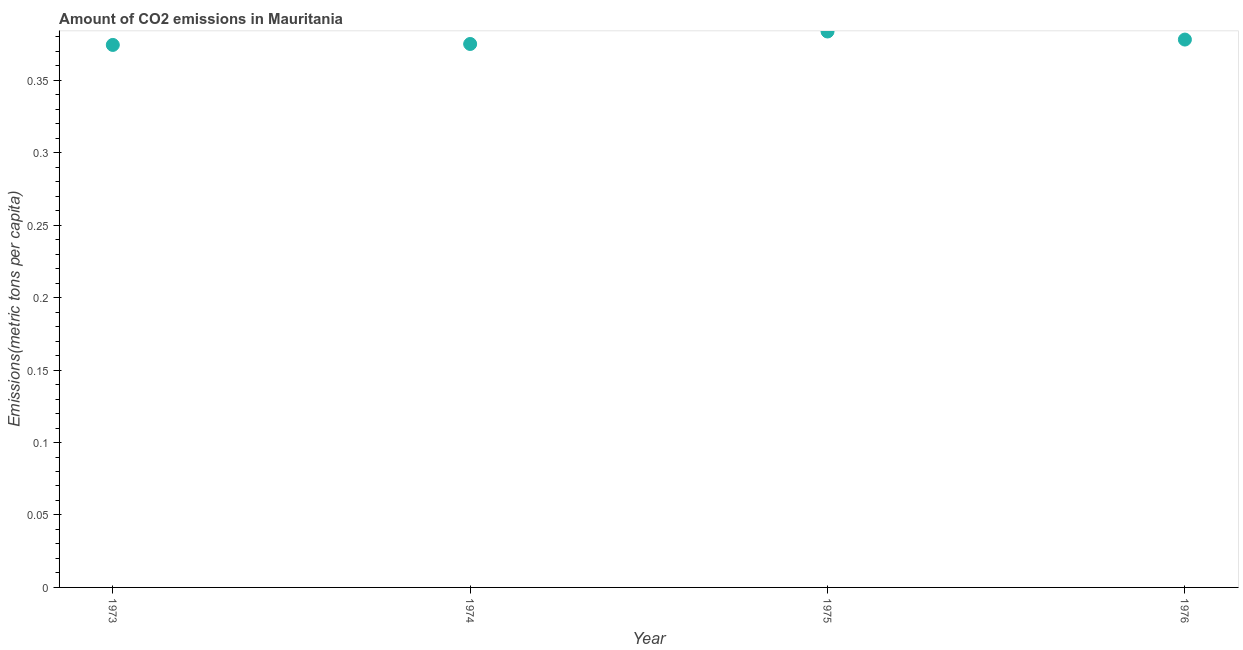What is the amount of co2 emissions in 1976?
Your response must be concise. 0.38. Across all years, what is the maximum amount of co2 emissions?
Your answer should be very brief. 0.38. Across all years, what is the minimum amount of co2 emissions?
Offer a terse response. 0.37. In which year was the amount of co2 emissions maximum?
Your response must be concise. 1975. In which year was the amount of co2 emissions minimum?
Ensure brevity in your answer.  1973. What is the sum of the amount of co2 emissions?
Offer a terse response. 1.51. What is the difference between the amount of co2 emissions in 1973 and 1976?
Keep it short and to the point. -0. What is the average amount of co2 emissions per year?
Provide a succinct answer. 0.38. What is the median amount of co2 emissions?
Keep it short and to the point. 0.38. In how many years, is the amount of co2 emissions greater than 0.30000000000000004 metric tons per capita?
Your answer should be very brief. 4. What is the ratio of the amount of co2 emissions in 1973 to that in 1976?
Give a very brief answer. 0.99. Is the difference between the amount of co2 emissions in 1973 and 1976 greater than the difference between any two years?
Your answer should be very brief. No. What is the difference between the highest and the second highest amount of co2 emissions?
Give a very brief answer. 0.01. Is the sum of the amount of co2 emissions in 1974 and 1975 greater than the maximum amount of co2 emissions across all years?
Keep it short and to the point. Yes. What is the difference between the highest and the lowest amount of co2 emissions?
Your answer should be very brief. 0.01. In how many years, is the amount of co2 emissions greater than the average amount of co2 emissions taken over all years?
Offer a very short reply. 2. How many dotlines are there?
Give a very brief answer. 1. How many years are there in the graph?
Your answer should be compact. 4. What is the difference between two consecutive major ticks on the Y-axis?
Make the answer very short. 0.05. Does the graph contain grids?
Give a very brief answer. No. What is the title of the graph?
Your answer should be very brief. Amount of CO2 emissions in Mauritania. What is the label or title of the X-axis?
Offer a terse response. Year. What is the label or title of the Y-axis?
Give a very brief answer. Emissions(metric tons per capita). What is the Emissions(metric tons per capita) in 1973?
Provide a succinct answer. 0.37. What is the Emissions(metric tons per capita) in 1974?
Provide a succinct answer. 0.38. What is the Emissions(metric tons per capita) in 1975?
Make the answer very short. 0.38. What is the Emissions(metric tons per capita) in 1976?
Give a very brief answer. 0.38. What is the difference between the Emissions(metric tons per capita) in 1973 and 1974?
Offer a very short reply. -0. What is the difference between the Emissions(metric tons per capita) in 1973 and 1975?
Offer a very short reply. -0.01. What is the difference between the Emissions(metric tons per capita) in 1973 and 1976?
Offer a very short reply. -0. What is the difference between the Emissions(metric tons per capita) in 1974 and 1975?
Ensure brevity in your answer.  -0.01. What is the difference between the Emissions(metric tons per capita) in 1974 and 1976?
Give a very brief answer. -0. What is the difference between the Emissions(metric tons per capita) in 1975 and 1976?
Offer a very short reply. 0.01. What is the ratio of the Emissions(metric tons per capita) in 1973 to that in 1974?
Keep it short and to the point. 1. What is the ratio of the Emissions(metric tons per capita) in 1973 to that in 1975?
Offer a terse response. 0.98. What is the ratio of the Emissions(metric tons per capita) in 1973 to that in 1976?
Give a very brief answer. 0.99. What is the ratio of the Emissions(metric tons per capita) in 1974 to that in 1975?
Make the answer very short. 0.98. 